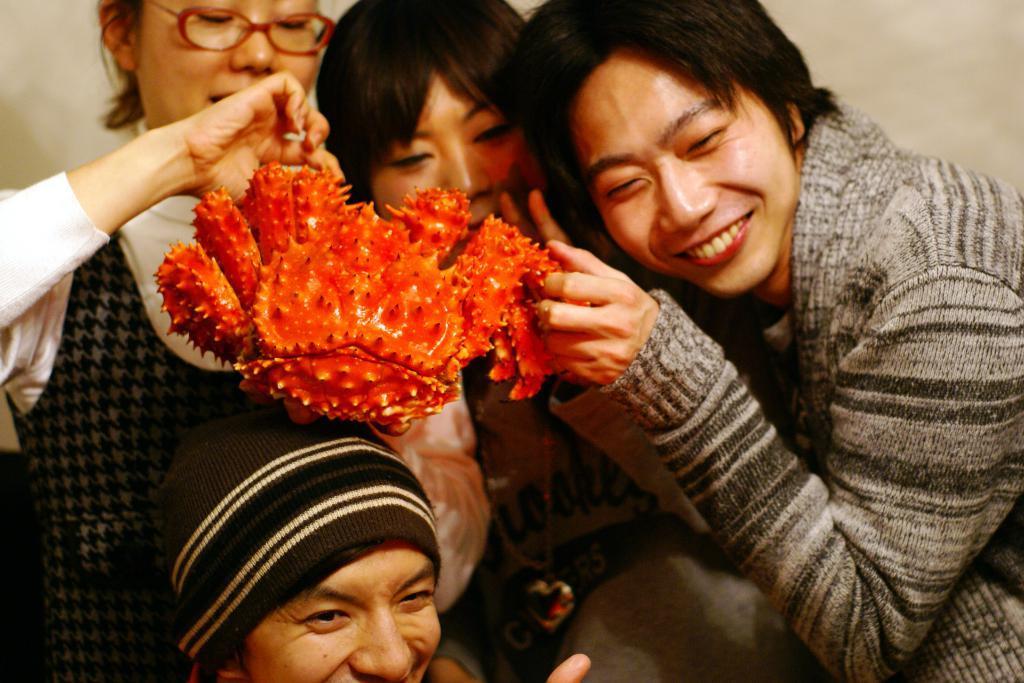In one or two sentences, can you explain what this image depicts? This is a zoomed in picture. In the foreground there is a person wearing hat and seems to be smiling. In the center we can see the three people standing and holding an orange color object. In the background there is a wall. 